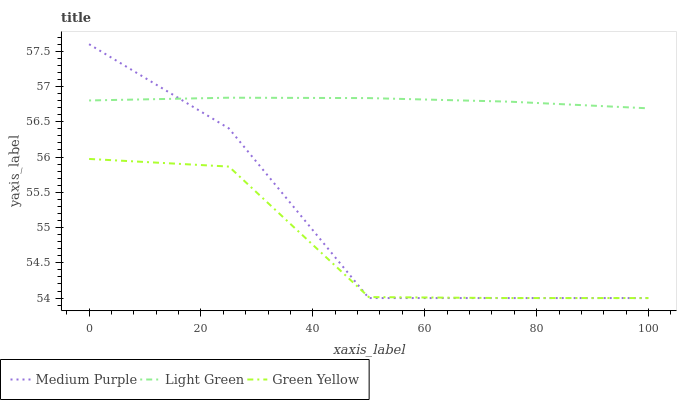Does Green Yellow have the minimum area under the curve?
Answer yes or no. Yes. Does Light Green have the maximum area under the curve?
Answer yes or no. Yes. Does Light Green have the minimum area under the curve?
Answer yes or no. No. Does Green Yellow have the maximum area under the curve?
Answer yes or no. No. Is Light Green the smoothest?
Answer yes or no. Yes. Is Medium Purple the roughest?
Answer yes or no. Yes. Is Green Yellow the smoothest?
Answer yes or no. No. Is Green Yellow the roughest?
Answer yes or no. No. Does Light Green have the lowest value?
Answer yes or no. No. Does Light Green have the highest value?
Answer yes or no. No. Is Green Yellow less than Light Green?
Answer yes or no. Yes. Is Light Green greater than Green Yellow?
Answer yes or no. Yes. Does Green Yellow intersect Light Green?
Answer yes or no. No. 